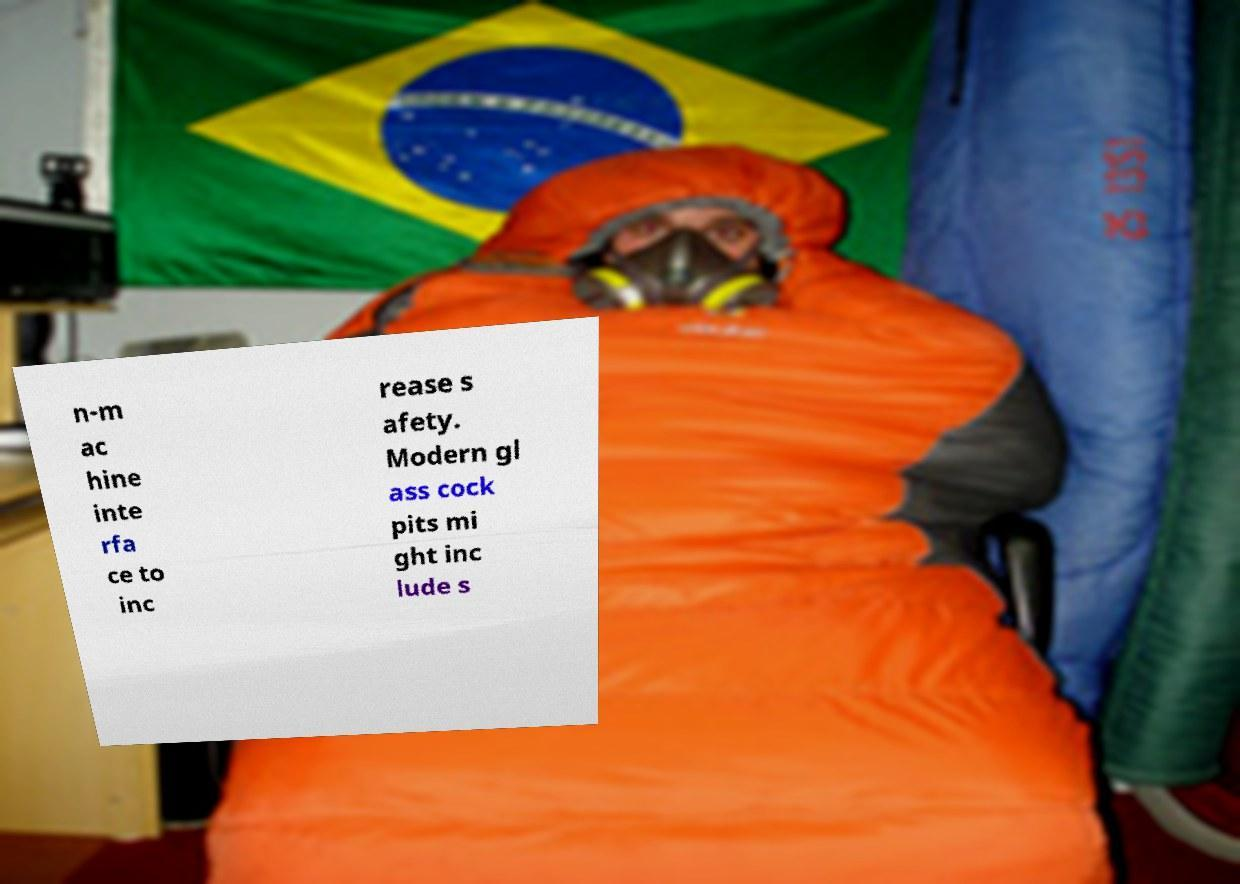What messages or text are displayed in this image? I need them in a readable, typed format. n-m ac hine inte rfa ce to inc rease s afety. Modern gl ass cock pits mi ght inc lude s 